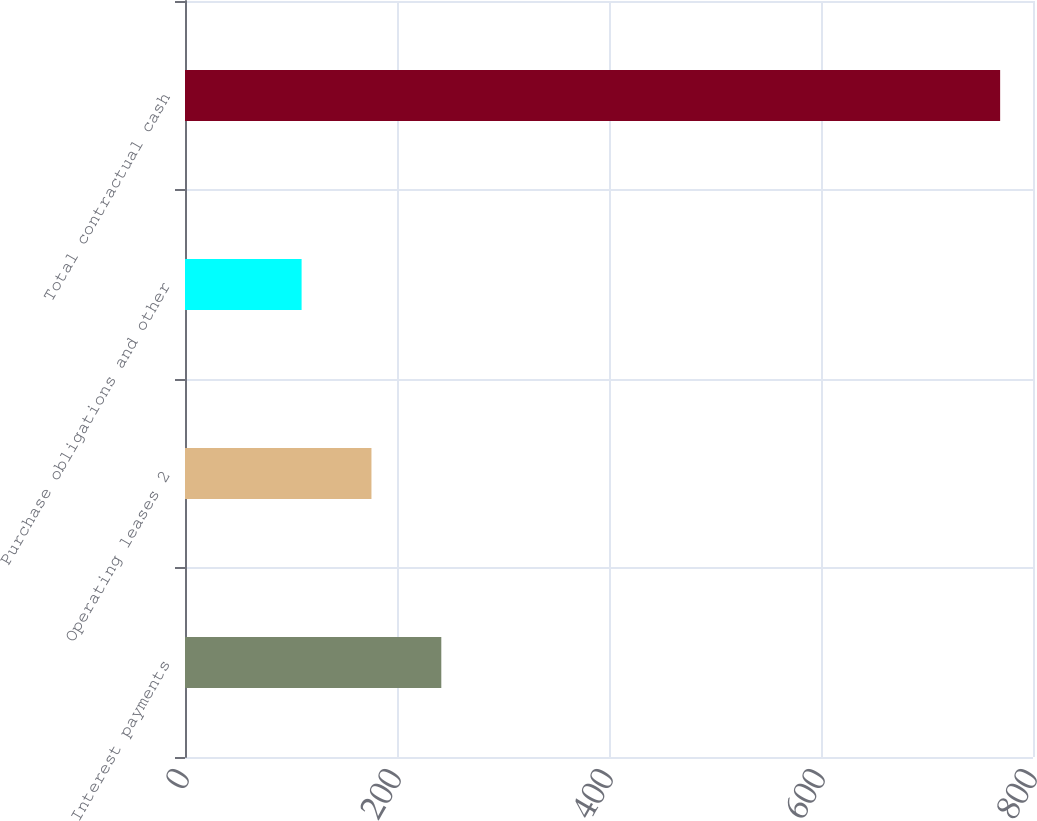<chart> <loc_0><loc_0><loc_500><loc_500><bar_chart><fcel>Interest payments<fcel>Operating leases 2<fcel>Purchase obligations and other<fcel>Total contractual cash<nl><fcel>241.8<fcel>175.9<fcel>110<fcel>769<nl></chart> 